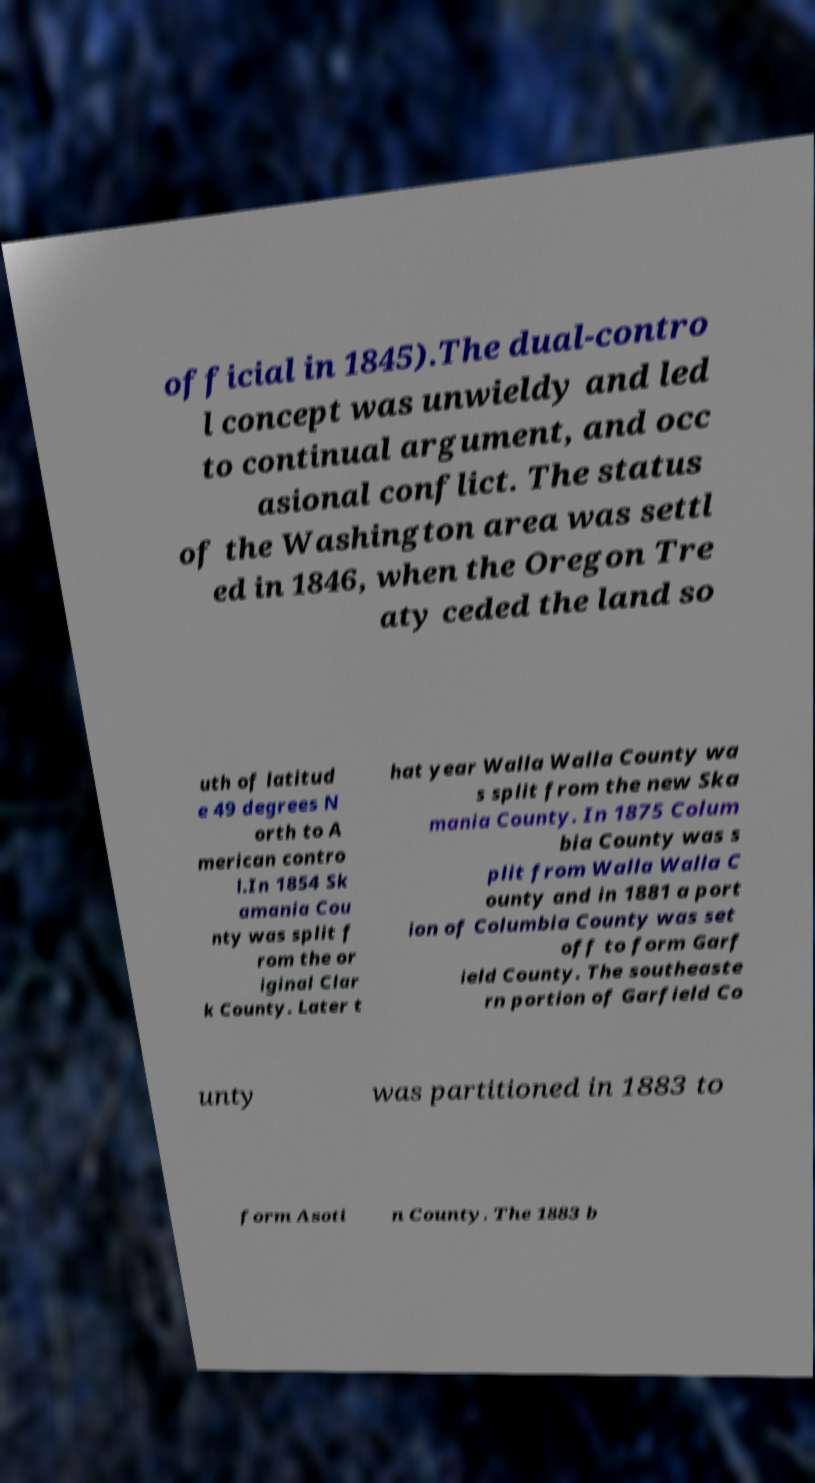For documentation purposes, I need the text within this image transcribed. Could you provide that? official in 1845).The dual-contro l concept was unwieldy and led to continual argument, and occ asional conflict. The status of the Washington area was settl ed in 1846, when the Oregon Tre aty ceded the land so uth of latitud e 49 degrees N orth to A merican contro l.In 1854 Sk amania Cou nty was split f rom the or iginal Clar k County. Later t hat year Walla Walla County wa s split from the new Ska mania County. In 1875 Colum bia County was s plit from Walla Walla C ounty and in 1881 a port ion of Columbia County was set off to form Garf ield County. The southeaste rn portion of Garfield Co unty was partitioned in 1883 to form Asoti n County. The 1883 b 